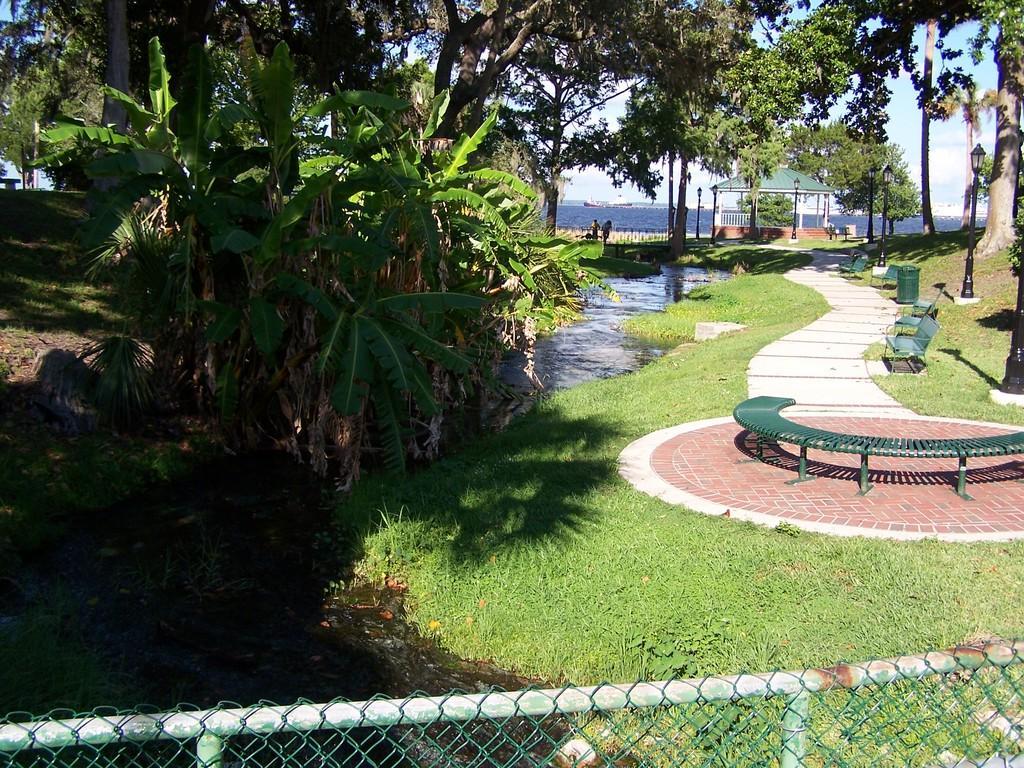In one or two sentences, can you explain what this image depicts? This image consists of many trees. At the bottom, there is green grass and water. On the right, we can see a path and a bench made up of metal. In the background, we can see a shed. At the bottom, there is a fencing. 